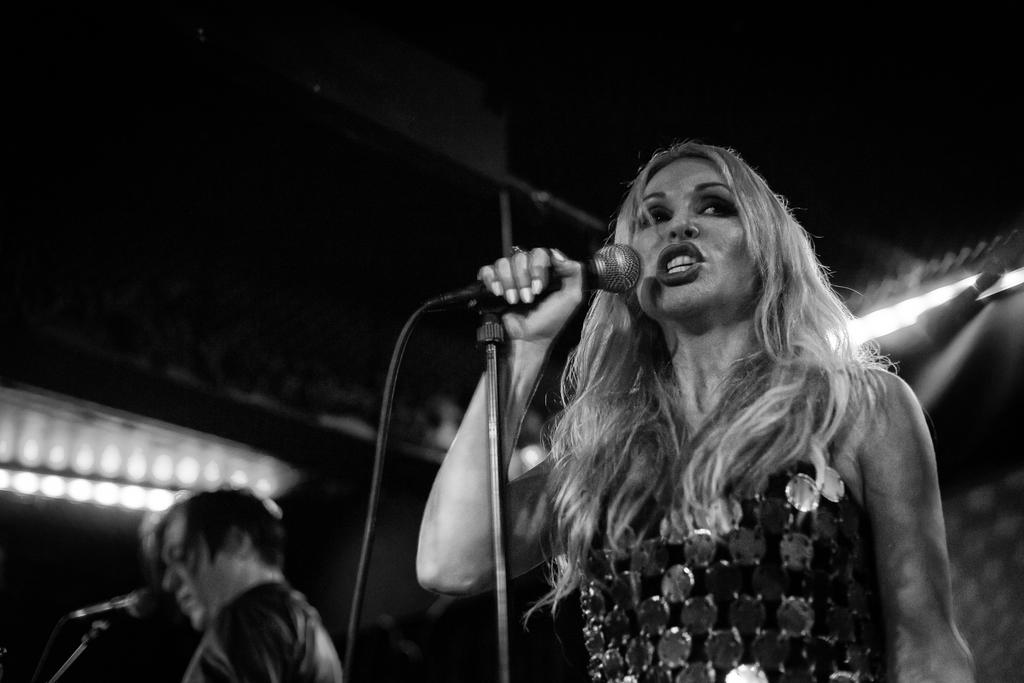What is the person in the image doing? The person in the image is standing and singing. What is the person holding while singing? The person is holding a microphone in their hand. Is there anyone else present in the image? Yes, there is another person standing nearby in the image. What can be seen in the background or surrounding the scene? There are lights visible in the image. What type of lettuce is on the throne in the image? There is no lettuce or throne present in the image. 